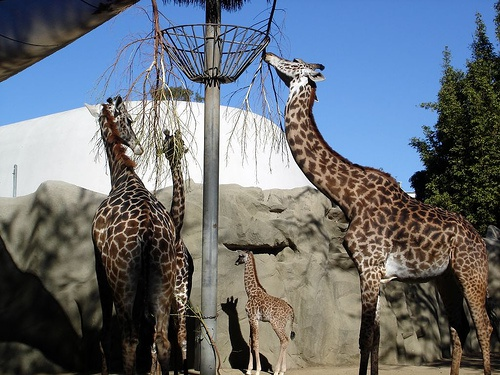Describe the objects in this image and their specific colors. I can see giraffe in black, maroon, and gray tones, giraffe in black, gray, and maroon tones, giraffe in black, gray, and darkgray tones, and giraffe in black, tan, gray, and maroon tones in this image. 